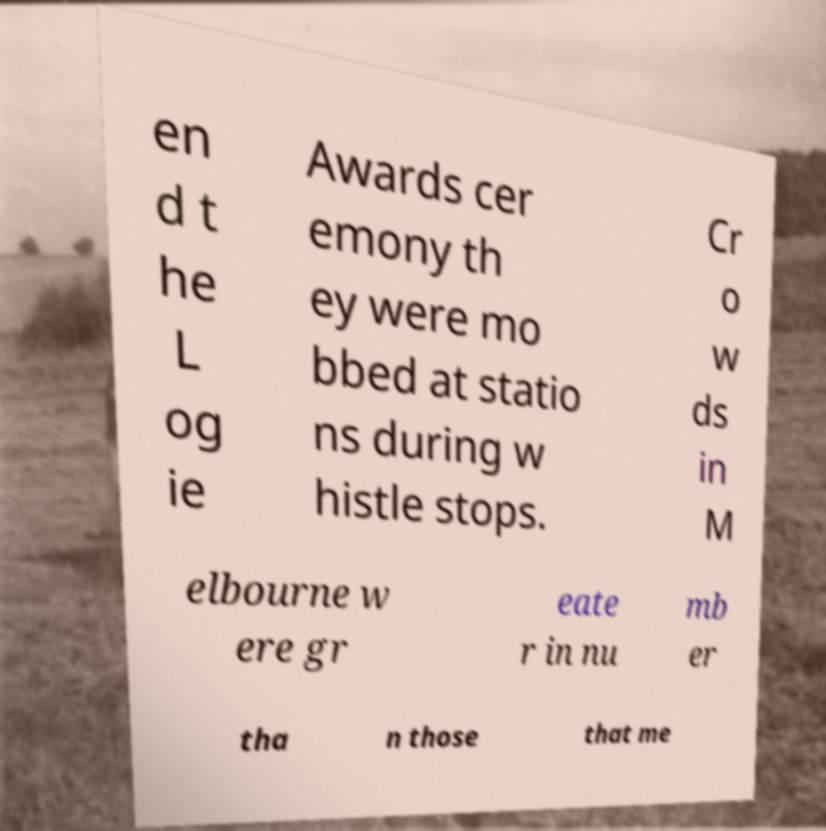Can you read and provide the text displayed in the image?This photo seems to have some interesting text. Can you extract and type it out for me? en d t he L og ie Awards cer emony th ey were mo bbed at statio ns during w histle stops. Cr o w ds in M elbourne w ere gr eate r in nu mb er tha n those that me 